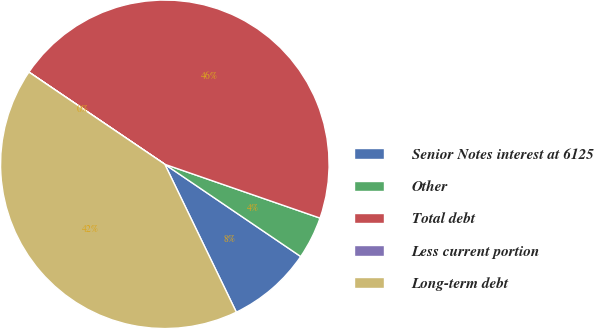Convert chart. <chart><loc_0><loc_0><loc_500><loc_500><pie_chart><fcel>Senior Notes interest at 6125<fcel>Other<fcel>Total debt<fcel>Less current portion<fcel>Long-term debt<nl><fcel>8.34%<fcel>4.18%<fcel>45.82%<fcel>0.01%<fcel>41.65%<nl></chart> 